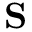Convert formula to latex. <formula><loc_0><loc_0><loc_500><loc_500>S</formula> 